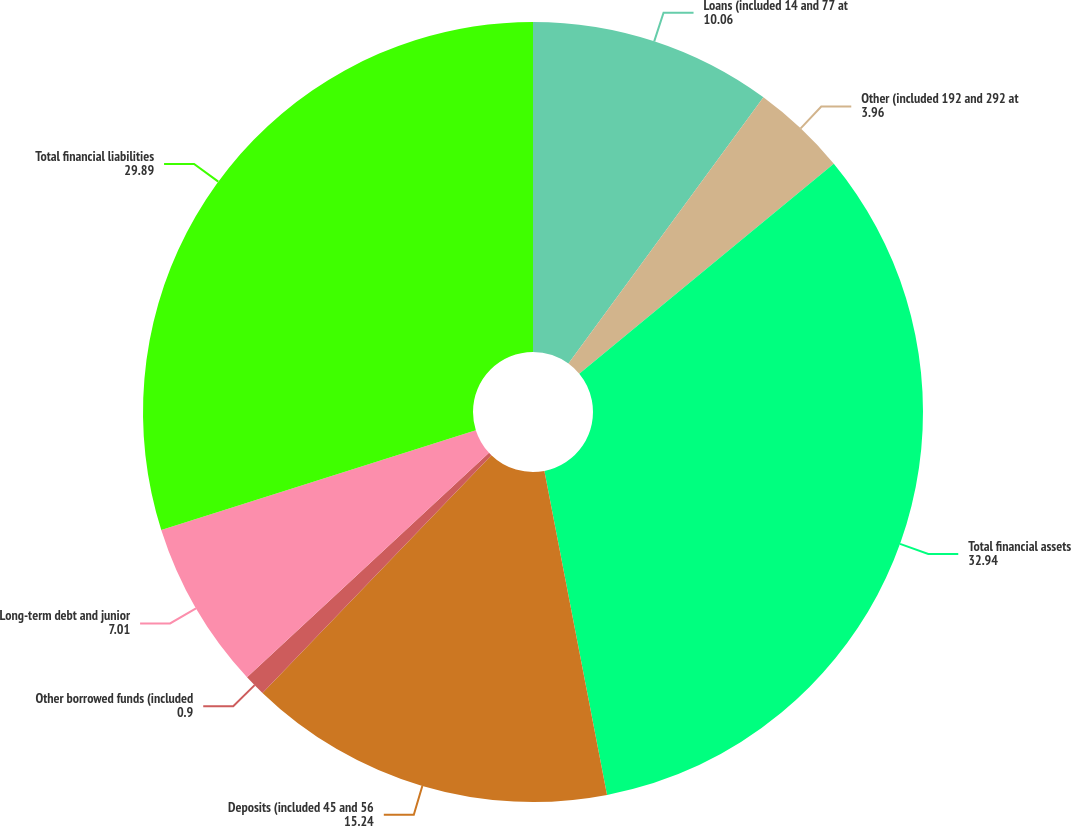Convert chart. <chart><loc_0><loc_0><loc_500><loc_500><pie_chart><fcel>Loans (included 14 and 77 at<fcel>Other (included 192 and 292 at<fcel>Total financial assets<fcel>Deposits (included 45 and 56<fcel>Other borrowed funds (included<fcel>Long-term debt and junior<fcel>Total financial liabilities<nl><fcel>10.06%<fcel>3.96%<fcel>32.94%<fcel>15.24%<fcel>0.9%<fcel>7.01%<fcel>29.89%<nl></chart> 